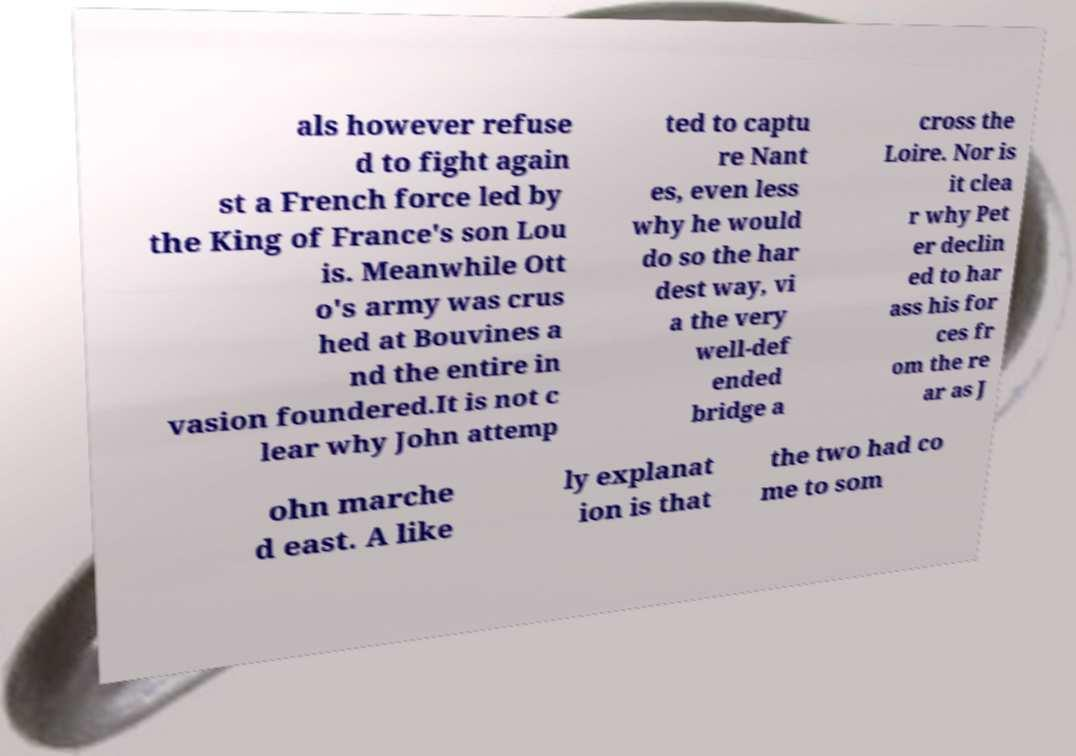For documentation purposes, I need the text within this image transcribed. Could you provide that? als however refuse d to fight again st a French force led by the King of France's son Lou is. Meanwhile Ott o's army was crus hed at Bouvines a nd the entire in vasion foundered.It is not c lear why John attemp ted to captu re Nant es, even less why he would do so the har dest way, vi a the very well-def ended bridge a cross the Loire. Nor is it clea r why Pet er declin ed to har ass his for ces fr om the re ar as J ohn marche d east. A like ly explanat ion is that the two had co me to som 